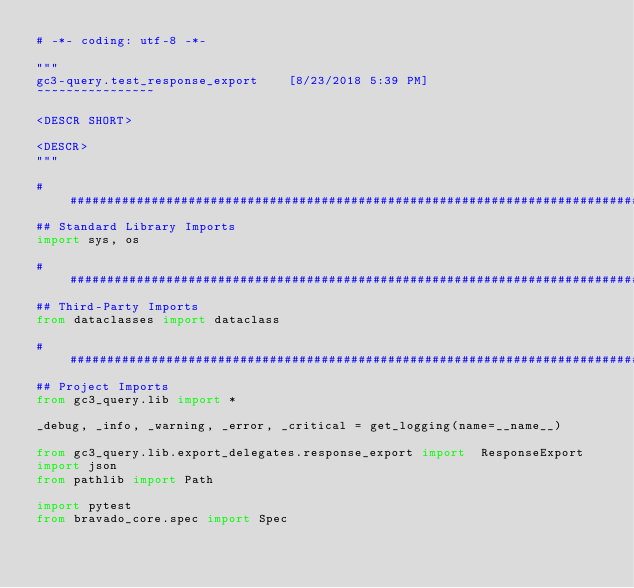Convert code to text. <code><loc_0><loc_0><loc_500><loc_500><_Python_># -*- coding: utf-8 -*-

"""
gc3-query.test_response_export    [8/23/2018 5:39 PM]
~~~~~~~~~~~~~~~~

<DESCR SHORT>

<DESCR>
"""

################################################################################
## Standard Library Imports
import sys, os

################################################################################
## Third-Party Imports
from dataclasses import dataclass

################################################################################
## Project Imports
from gc3_query.lib import *

_debug, _info, _warning, _error, _critical = get_logging(name=__name__)

from gc3_query.lib.export_delegates.response_export import  ResponseExport
import json
from pathlib import Path

import pytest
from bravado_core.spec import Spec
</code> 